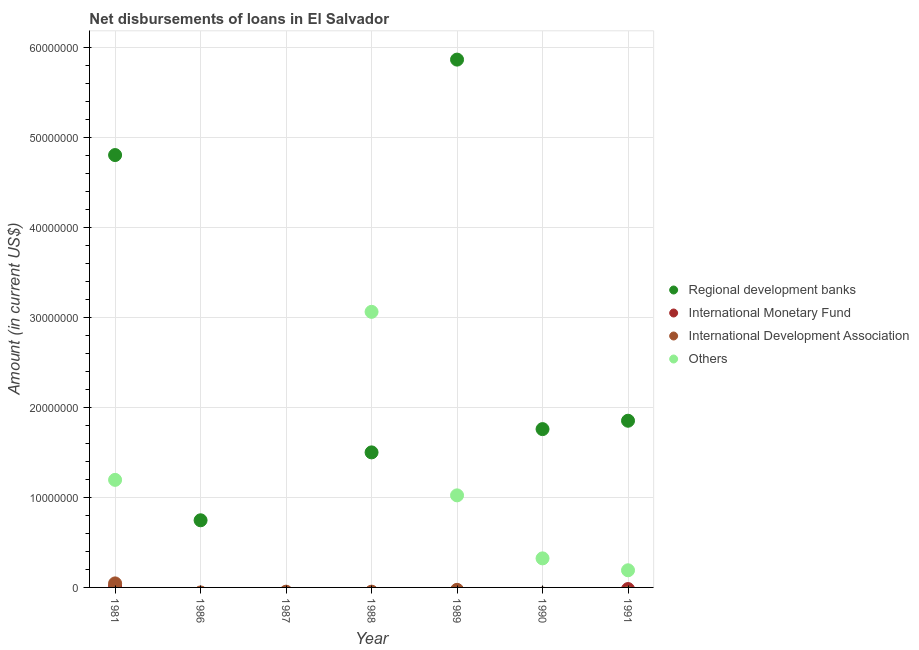How many different coloured dotlines are there?
Offer a very short reply. 4. What is the amount of loan disimbursed by other organisations in 1981?
Keep it short and to the point. 1.20e+07. Across all years, what is the maximum amount of loan disimbursed by international development association?
Provide a succinct answer. 4.47e+05. Across all years, what is the minimum amount of loan disimbursed by regional development banks?
Your answer should be compact. 0. In which year was the amount of loan disimbursed by international monetary fund maximum?
Make the answer very short. 1981. What is the total amount of loan disimbursed by other organisations in the graph?
Your answer should be compact. 5.79e+07. What is the difference between the amount of loan disimbursed by regional development banks in 1986 and that in 1988?
Keep it short and to the point. -7.54e+06. What is the difference between the amount of loan disimbursed by other organisations in 1989 and the amount of loan disimbursed by regional development banks in 1991?
Your answer should be very brief. -8.29e+06. What is the average amount of loan disimbursed by regional development banks per year?
Your answer should be compact. 2.36e+07. In the year 1981, what is the difference between the amount of loan disimbursed by regional development banks and amount of loan disimbursed by international development association?
Offer a very short reply. 4.76e+07. In how many years, is the amount of loan disimbursed by international development association greater than 56000000 US$?
Your answer should be compact. 0. What is the ratio of the amount of loan disimbursed by regional development banks in 1986 to that in 1988?
Offer a very short reply. 0.5. What is the difference between the highest and the second highest amount of loan disimbursed by other organisations?
Make the answer very short. 1.87e+07. What is the difference between the highest and the lowest amount of loan disimbursed by international monetary fund?
Make the answer very short. 1.56e+05. Is the sum of the amount of loan disimbursed by regional development banks in 1990 and 1991 greater than the maximum amount of loan disimbursed by international development association across all years?
Give a very brief answer. Yes. How many years are there in the graph?
Make the answer very short. 7. What is the difference between two consecutive major ticks on the Y-axis?
Offer a terse response. 1.00e+07. Where does the legend appear in the graph?
Ensure brevity in your answer.  Center right. How many legend labels are there?
Your answer should be very brief. 4. How are the legend labels stacked?
Your answer should be compact. Vertical. What is the title of the graph?
Ensure brevity in your answer.  Net disbursements of loans in El Salvador. Does "Tertiary education" appear as one of the legend labels in the graph?
Provide a short and direct response. No. What is the label or title of the X-axis?
Provide a succinct answer. Year. What is the Amount (in current US$) in Regional development banks in 1981?
Provide a short and direct response. 4.80e+07. What is the Amount (in current US$) in International Monetary Fund in 1981?
Provide a short and direct response. 1.56e+05. What is the Amount (in current US$) in International Development Association in 1981?
Keep it short and to the point. 4.47e+05. What is the Amount (in current US$) in Others in 1981?
Your answer should be compact. 1.20e+07. What is the Amount (in current US$) of Regional development banks in 1986?
Make the answer very short. 7.46e+06. What is the Amount (in current US$) of International Development Association in 1986?
Give a very brief answer. 0. What is the Amount (in current US$) of Others in 1986?
Offer a very short reply. 0. What is the Amount (in current US$) of International Development Association in 1987?
Keep it short and to the point. 0. What is the Amount (in current US$) of Regional development banks in 1988?
Provide a short and direct response. 1.50e+07. What is the Amount (in current US$) in Others in 1988?
Give a very brief answer. 3.06e+07. What is the Amount (in current US$) in Regional development banks in 1989?
Make the answer very short. 5.87e+07. What is the Amount (in current US$) of International Monetary Fund in 1989?
Your answer should be very brief. 0. What is the Amount (in current US$) of International Development Association in 1989?
Your response must be concise. 0. What is the Amount (in current US$) in Others in 1989?
Provide a succinct answer. 1.02e+07. What is the Amount (in current US$) in Regional development banks in 1990?
Offer a very short reply. 1.76e+07. What is the Amount (in current US$) in Others in 1990?
Offer a very short reply. 3.23e+06. What is the Amount (in current US$) in Regional development banks in 1991?
Provide a succinct answer. 1.85e+07. What is the Amount (in current US$) in International Monetary Fund in 1991?
Keep it short and to the point. 0. What is the Amount (in current US$) in Others in 1991?
Ensure brevity in your answer.  1.90e+06. Across all years, what is the maximum Amount (in current US$) of Regional development banks?
Your answer should be very brief. 5.87e+07. Across all years, what is the maximum Amount (in current US$) in International Monetary Fund?
Make the answer very short. 1.56e+05. Across all years, what is the maximum Amount (in current US$) in International Development Association?
Provide a short and direct response. 4.47e+05. Across all years, what is the maximum Amount (in current US$) of Others?
Offer a very short reply. 3.06e+07. Across all years, what is the minimum Amount (in current US$) of Others?
Offer a terse response. 0. What is the total Amount (in current US$) in Regional development banks in the graph?
Provide a short and direct response. 1.65e+08. What is the total Amount (in current US$) of International Monetary Fund in the graph?
Provide a succinct answer. 1.56e+05. What is the total Amount (in current US$) in International Development Association in the graph?
Your answer should be very brief. 4.47e+05. What is the total Amount (in current US$) of Others in the graph?
Your response must be concise. 5.79e+07. What is the difference between the Amount (in current US$) of Regional development banks in 1981 and that in 1986?
Give a very brief answer. 4.06e+07. What is the difference between the Amount (in current US$) in Regional development banks in 1981 and that in 1988?
Your answer should be compact. 3.30e+07. What is the difference between the Amount (in current US$) in Others in 1981 and that in 1988?
Make the answer very short. -1.87e+07. What is the difference between the Amount (in current US$) of Regional development banks in 1981 and that in 1989?
Your answer should be very brief. -1.06e+07. What is the difference between the Amount (in current US$) of Others in 1981 and that in 1989?
Offer a very short reply. 1.72e+06. What is the difference between the Amount (in current US$) in Regional development banks in 1981 and that in 1990?
Your answer should be compact. 3.05e+07. What is the difference between the Amount (in current US$) of Others in 1981 and that in 1990?
Offer a terse response. 8.72e+06. What is the difference between the Amount (in current US$) in Regional development banks in 1981 and that in 1991?
Your answer should be very brief. 2.95e+07. What is the difference between the Amount (in current US$) in Others in 1981 and that in 1991?
Make the answer very short. 1.00e+07. What is the difference between the Amount (in current US$) of Regional development banks in 1986 and that in 1988?
Provide a succinct answer. -7.54e+06. What is the difference between the Amount (in current US$) of Regional development banks in 1986 and that in 1989?
Offer a very short reply. -5.12e+07. What is the difference between the Amount (in current US$) in Regional development banks in 1986 and that in 1990?
Make the answer very short. -1.01e+07. What is the difference between the Amount (in current US$) of Regional development banks in 1986 and that in 1991?
Provide a short and direct response. -1.11e+07. What is the difference between the Amount (in current US$) of Regional development banks in 1988 and that in 1989?
Give a very brief answer. -4.36e+07. What is the difference between the Amount (in current US$) of Others in 1988 and that in 1989?
Provide a succinct answer. 2.04e+07. What is the difference between the Amount (in current US$) of Regional development banks in 1988 and that in 1990?
Your response must be concise. -2.59e+06. What is the difference between the Amount (in current US$) of Others in 1988 and that in 1990?
Your response must be concise. 2.74e+07. What is the difference between the Amount (in current US$) of Regional development banks in 1988 and that in 1991?
Your answer should be compact. -3.52e+06. What is the difference between the Amount (in current US$) in Others in 1988 and that in 1991?
Provide a succinct answer. 2.87e+07. What is the difference between the Amount (in current US$) in Regional development banks in 1989 and that in 1990?
Your answer should be very brief. 4.11e+07. What is the difference between the Amount (in current US$) of Others in 1989 and that in 1990?
Provide a succinct answer. 7.00e+06. What is the difference between the Amount (in current US$) of Regional development banks in 1989 and that in 1991?
Make the answer very short. 4.01e+07. What is the difference between the Amount (in current US$) in Others in 1989 and that in 1991?
Offer a very short reply. 8.32e+06. What is the difference between the Amount (in current US$) of Regional development banks in 1990 and that in 1991?
Ensure brevity in your answer.  -9.30e+05. What is the difference between the Amount (in current US$) of Others in 1990 and that in 1991?
Your answer should be compact. 1.32e+06. What is the difference between the Amount (in current US$) of Regional development banks in 1981 and the Amount (in current US$) of Others in 1988?
Offer a terse response. 1.74e+07. What is the difference between the Amount (in current US$) of International Monetary Fund in 1981 and the Amount (in current US$) of Others in 1988?
Give a very brief answer. -3.05e+07. What is the difference between the Amount (in current US$) in International Development Association in 1981 and the Amount (in current US$) in Others in 1988?
Offer a terse response. -3.02e+07. What is the difference between the Amount (in current US$) of Regional development banks in 1981 and the Amount (in current US$) of Others in 1989?
Ensure brevity in your answer.  3.78e+07. What is the difference between the Amount (in current US$) of International Monetary Fund in 1981 and the Amount (in current US$) of Others in 1989?
Your answer should be compact. -1.01e+07. What is the difference between the Amount (in current US$) in International Development Association in 1981 and the Amount (in current US$) in Others in 1989?
Keep it short and to the point. -9.78e+06. What is the difference between the Amount (in current US$) in Regional development banks in 1981 and the Amount (in current US$) in Others in 1990?
Give a very brief answer. 4.48e+07. What is the difference between the Amount (in current US$) of International Monetary Fund in 1981 and the Amount (in current US$) of Others in 1990?
Your response must be concise. -3.07e+06. What is the difference between the Amount (in current US$) of International Development Association in 1981 and the Amount (in current US$) of Others in 1990?
Your answer should be very brief. -2.78e+06. What is the difference between the Amount (in current US$) of Regional development banks in 1981 and the Amount (in current US$) of Others in 1991?
Provide a succinct answer. 4.61e+07. What is the difference between the Amount (in current US$) in International Monetary Fund in 1981 and the Amount (in current US$) in Others in 1991?
Ensure brevity in your answer.  -1.75e+06. What is the difference between the Amount (in current US$) of International Development Association in 1981 and the Amount (in current US$) of Others in 1991?
Your answer should be compact. -1.46e+06. What is the difference between the Amount (in current US$) in Regional development banks in 1986 and the Amount (in current US$) in Others in 1988?
Offer a very short reply. -2.32e+07. What is the difference between the Amount (in current US$) in Regional development banks in 1986 and the Amount (in current US$) in Others in 1989?
Give a very brief answer. -2.77e+06. What is the difference between the Amount (in current US$) in Regional development banks in 1986 and the Amount (in current US$) in Others in 1990?
Your answer should be compact. 4.23e+06. What is the difference between the Amount (in current US$) in Regional development banks in 1986 and the Amount (in current US$) in Others in 1991?
Make the answer very short. 5.56e+06. What is the difference between the Amount (in current US$) of Regional development banks in 1988 and the Amount (in current US$) of Others in 1989?
Provide a short and direct response. 4.78e+06. What is the difference between the Amount (in current US$) of Regional development banks in 1988 and the Amount (in current US$) of Others in 1990?
Your answer should be very brief. 1.18e+07. What is the difference between the Amount (in current US$) in Regional development banks in 1988 and the Amount (in current US$) in Others in 1991?
Provide a short and direct response. 1.31e+07. What is the difference between the Amount (in current US$) in Regional development banks in 1989 and the Amount (in current US$) in Others in 1990?
Your response must be concise. 5.54e+07. What is the difference between the Amount (in current US$) of Regional development banks in 1989 and the Amount (in current US$) of Others in 1991?
Offer a terse response. 5.67e+07. What is the difference between the Amount (in current US$) in Regional development banks in 1990 and the Amount (in current US$) in Others in 1991?
Keep it short and to the point. 1.57e+07. What is the average Amount (in current US$) in Regional development banks per year?
Your answer should be compact. 2.36e+07. What is the average Amount (in current US$) of International Monetary Fund per year?
Your answer should be compact. 2.23e+04. What is the average Amount (in current US$) of International Development Association per year?
Keep it short and to the point. 6.39e+04. What is the average Amount (in current US$) of Others per year?
Your response must be concise. 8.28e+06. In the year 1981, what is the difference between the Amount (in current US$) of Regional development banks and Amount (in current US$) of International Monetary Fund?
Provide a succinct answer. 4.79e+07. In the year 1981, what is the difference between the Amount (in current US$) of Regional development banks and Amount (in current US$) of International Development Association?
Offer a very short reply. 4.76e+07. In the year 1981, what is the difference between the Amount (in current US$) in Regional development banks and Amount (in current US$) in Others?
Your response must be concise. 3.61e+07. In the year 1981, what is the difference between the Amount (in current US$) of International Monetary Fund and Amount (in current US$) of International Development Association?
Ensure brevity in your answer.  -2.91e+05. In the year 1981, what is the difference between the Amount (in current US$) of International Monetary Fund and Amount (in current US$) of Others?
Offer a very short reply. -1.18e+07. In the year 1981, what is the difference between the Amount (in current US$) of International Development Association and Amount (in current US$) of Others?
Provide a succinct answer. -1.15e+07. In the year 1988, what is the difference between the Amount (in current US$) of Regional development banks and Amount (in current US$) of Others?
Offer a terse response. -1.56e+07. In the year 1989, what is the difference between the Amount (in current US$) in Regional development banks and Amount (in current US$) in Others?
Your answer should be compact. 4.84e+07. In the year 1990, what is the difference between the Amount (in current US$) in Regional development banks and Amount (in current US$) in Others?
Provide a succinct answer. 1.44e+07. In the year 1991, what is the difference between the Amount (in current US$) of Regional development banks and Amount (in current US$) of Others?
Give a very brief answer. 1.66e+07. What is the ratio of the Amount (in current US$) in Regional development banks in 1981 to that in 1986?
Provide a succinct answer. 6.44. What is the ratio of the Amount (in current US$) in Regional development banks in 1981 to that in 1988?
Give a very brief answer. 3.2. What is the ratio of the Amount (in current US$) in Others in 1981 to that in 1988?
Your answer should be very brief. 0.39. What is the ratio of the Amount (in current US$) in Regional development banks in 1981 to that in 1989?
Offer a terse response. 0.82. What is the ratio of the Amount (in current US$) of Others in 1981 to that in 1989?
Provide a short and direct response. 1.17. What is the ratio of the Amount (in current US$) of Regional development banks in 1981 to that in 1990?
Keep it short and to the point. 2.73. What is the ratio of the Amount (in current US$) of Others in 1981 to that in 1990?
Give a very brief answer. 3.7. What is the ratio of the Amount (in current US$) of Regional development banks in 1981 to that in 1991?
Offer a terse response. 2.59. What is the ratio of the Amount (in current US$) in Others in 1981 to that in 1991?
Your answer should be very brief. 6.27. What is the ratio of the Amount (in current US$) of Regional development banks in 1986 to that in 1988?
Make the answer very short. 0.5. What is the ratio of the Amount (in current US$) of Regional development banks in 1986 to that in 1989?
Provide a short and direct response. 0.13. What is the ratio of the Amount (in current US$) of Regional development banks in 1986 to that in 1990?
Your answer should be compact. 0.42. What is the ratio of the Amount (in current US$) of Regional development banks in 1986 to that in 1991?
Give a very brief answer. 0.4. What is the ratio of the Amount (in current US$) of Regional development banks in 1988 to that in 1989?
Provide a short and direct response. 0.26. What is the ratio of the Amount (in current US$) of Others in 1988 to that in 1989?
Your answer should be very brief. 2.99. What is the ratio of the Amount (in current US$) in Regional development banks in 1988 to that in 1990?
Offer a terse response. 0.85. What is the ratio of the Amount (in current US$) of Others in 1988 to that in 1990?
Keep it short and to the point. 9.48. What is the ratio of the Amount (in current US$) of Regional development banks in 1988 to that in 1991?
Your answer should be compact. 0.81. What is the ratio of the Amount (in current US$) in Others in 1988 to that in 1991?
Your answer should be very brief. 16.08. What is the ratio of the Amount (in current US$) in Regional development banks in 1989 to that in 1990?
Your response must be concise. 3.33. What is the ratio of the Amount (in current US$) in Others in 1989 to that in 1990?
Make the answer very short. 3.17. What is the ratio of the Amount (in current US$) in Regional development banks in 1989 to that in 1991?
Your response must be concise. 3.17. What is the ratio of the Amount (in current US$) of Others in 1989 to that in 1991?
Make the answer very short. 5.37. What is the ratio of the Amount (in current US$) in Regional development banks in 1990 to that in 1991?
Ensure brevity in your answer.  0.95. What is the ratio of the Amount (in current US$) in Others in 1990 to that in 1991?
Provide a short and direct response. 1.7. What is the difference between the highest and the second highest Amount (in current US$) in Regional development banks?
Provide a succinct answer. 1.06e+07. What is the difference between the highest and the second highest Amount (in current US$) of Others?
Offer a very short reply. 1.87e+07. What is the difference between the highest and the lowest Amount (in current US$) in Regional development banks?
Make the answer very short. 5.87e+07. What is the difference between the highest and the lowest Amount (in current US$) in International Monetary Fund?
Your response must be concise. 1.56e+05. What is the difference between the highest and the lowest Amount (in current US$) of International Development Association?
Your response must be concise. 4.47e+05. What is the difference between the highest and the lowest Amount (in current US$) in Others?
Keep it short and to the point. 3.06e+07. 